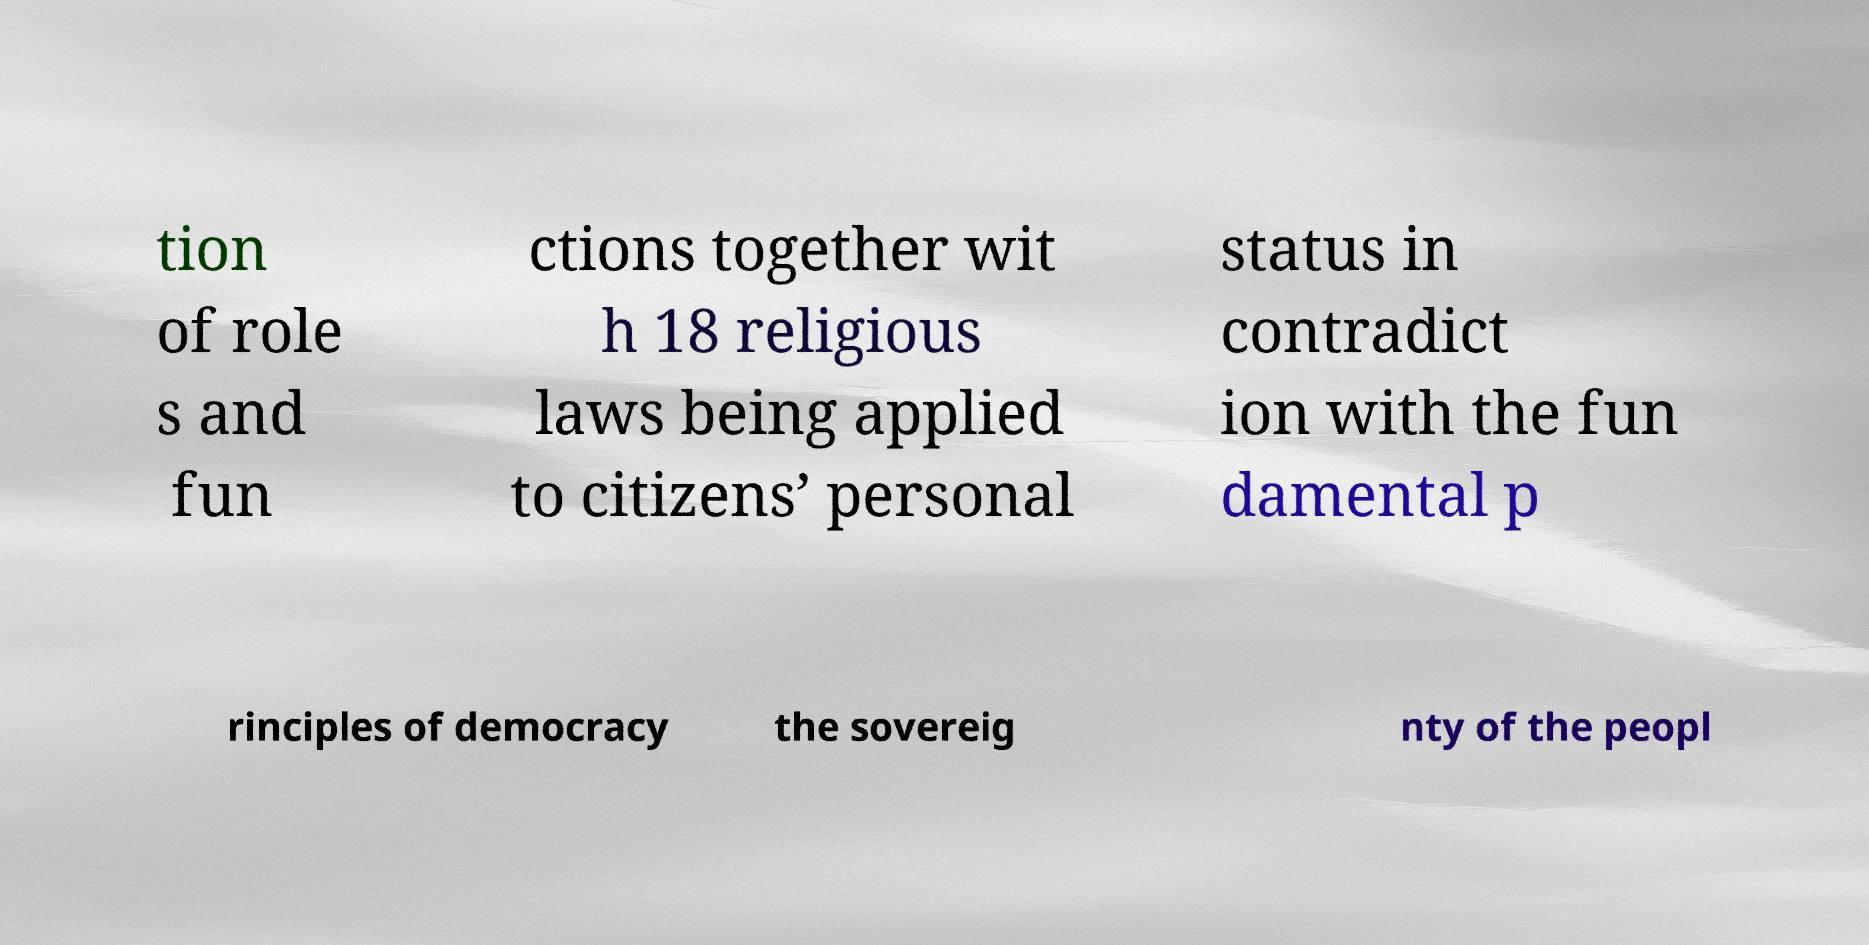Can you read and provide the text displayed in the image?This photo seems to have some interesting text. Can you extract and type it out for me? tion of role s and fun ctions together wit h 18 religious laws being applied to citizens’ personal status in contradict ion with the fun damental p rinciples of democracy the sovereig nty of the peopl 